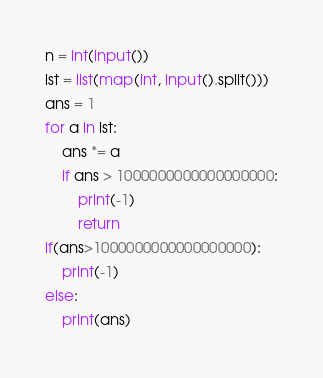<code> <loc_0><loc_0><loc_500><loc_500><_Python_>n = int(input())
lst = list(map(int, input().split()))
ans = 1
for a in lst: 
    ans *= a
	if ans > 1000000000000000000:
		print(-1)
		return
if(ans>1000000000000000000): 
    print(-1)
else:
    print(ans)
</code> 